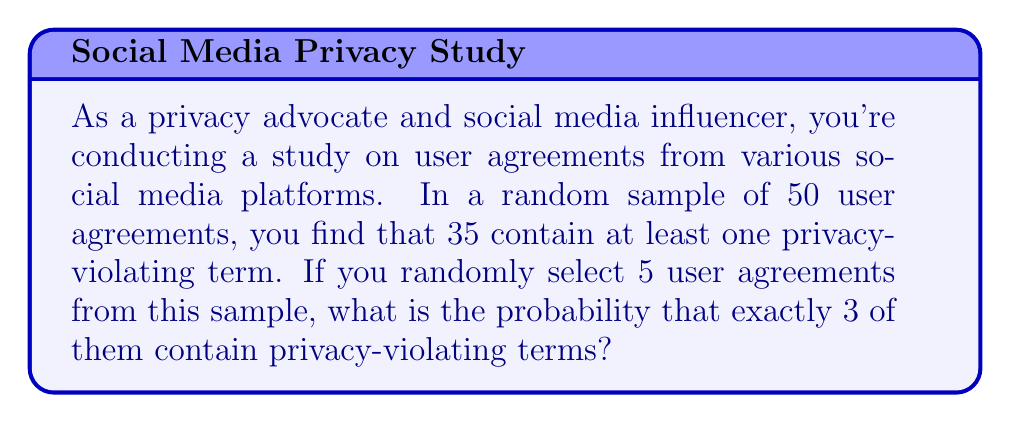Teach me how to tackle this problem. To solve this problem, we can use the hypergeometric distribution, which is appropriate when sampling without replacement from a finite population.

Let's define our variables:
$N = 50$ (total number of user agreements in the sample)
$K = 35$ (number of user agreements with privacy-violating terms)
$n = 5$ (number of user agreements we're selecting)
$k = 3$ (number of successful outcomes we're looking for)

The probability mass function for the hypergeometric distribution is:

$$P(X = k) = \frac{\binom{K}{k} \binom{N-K}{n-k}}{\binom{N}{n}}$$

Where $\binom{a}{b}$ represents the binomial coefficient, calculated as:

$$\binom{a}{b} = \frac{a!}{b!(a-b)!}$$

Let's calculate each part:

1) $\binom{K}{k} = \binom{35}{3} = \frac{35!}{3!(35-3)!} = 6545$

2) $\binom{N-K}{n-k} = \binom{15}{2} = \frac{15!}{2!(15-2)!} = 105$

3) $\binom{N}{n} = \binom{50}{5} = \frac{50!}{5!(50-5)!} = 2118760$

Now, let's plug these values into our probability mass function:

$$P(X = 3) = \frac{6545 \times 105}{2118760} = \frac{687225}{2118760} \approx 0.3243$$
Answer: The probability of selecting exactly 3 user agreements with privacy-violating terms out of 5 randomly selected agreements is approximately 0.3243 or 32.43%. 